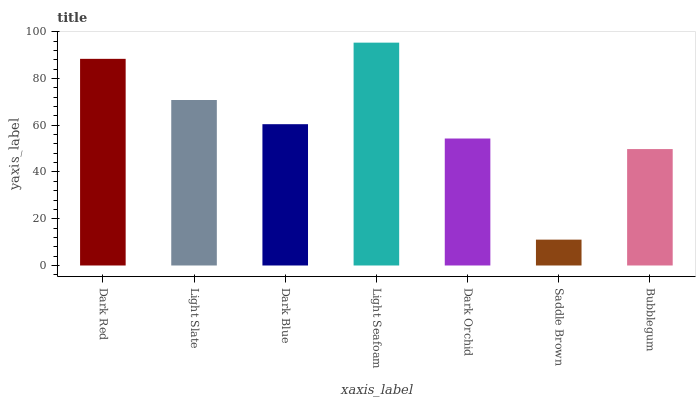Is Saddle Brown the minimum?
Answer yes or no. Yes. Is Light Seafoam the maximum?
Answer yes or no. Yes. Is Light Slate the minimum?
Answer yes or no. No. Is Light Slate the maximum?
Answer yes or no. No. Is Dark Red greater than Light Slate?
Answer yes or no. Yes. Is Light Slate less than Dark Red?
Answer yes or no. Yes. Is Light Slate greater than Dark Red?
Answer yes or no. No. Is Dark Red less than Light Slate?
Answer yes or no. No. Is Dark Blue the high median?
Answer yes or no. Yes. Is Dark Blue the low median?
Answer yes or no. Yes. Is Light Slate the high median?
Answer yes or no. No. Is Bubblegum the low median?
Answer yes or no. No. 